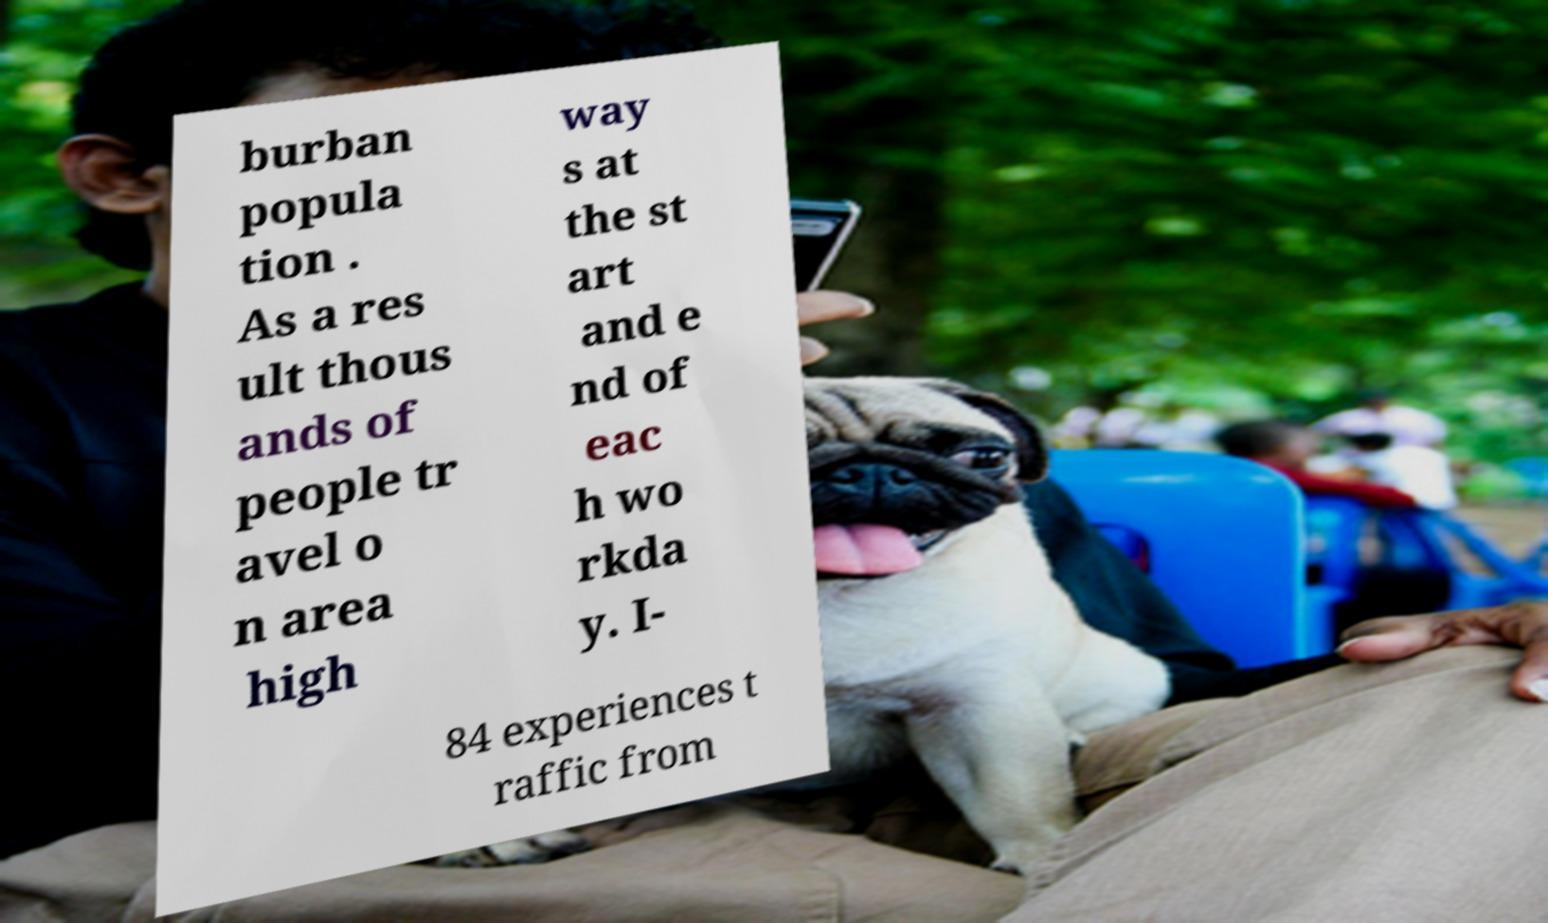Could you assist in decoding the text presented in this image and type it out clearly? burban popula tion . As a res ult thous ands of people tr avel o n area high way s at the st art and e nd of eac h wo rkda y. I- 84 experiences t raffic from 